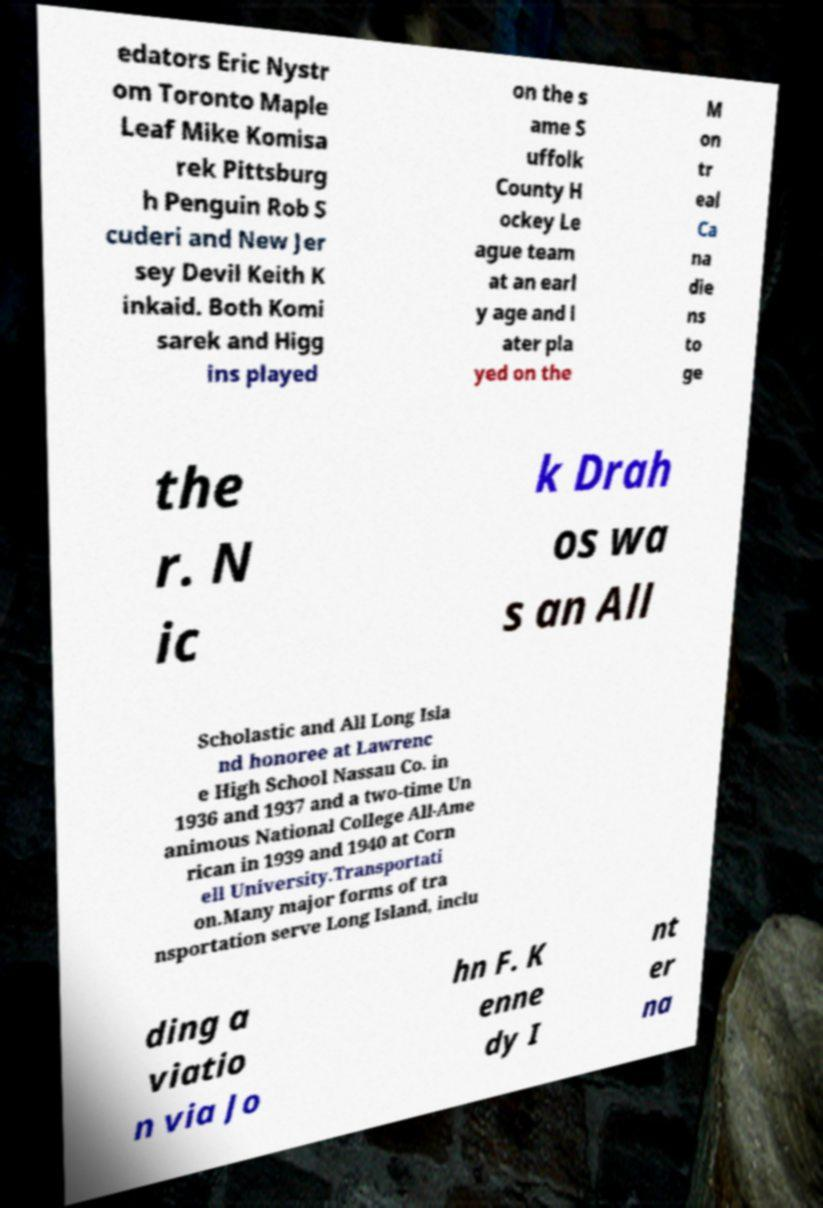I need the written content from this picture converted into text. Can you do that? edators Eric Nystr om Toronto Maple Leaf Mike Komisa rek Pittsburg h Penguin Rob S cuderi and New Jer sey Devil Keith K inkaid. Both Komi sarek and Higg ins played on the s ame S uffolk County H ockey Le ague team at an earl y age and l ater pla yed on the M on tr eal Ca na die ns to ge the r. N ic k Drah os wa s an All Scholastic and All Long Isla nd honoree at Lawrenc e High School Nassau Co. in 1936 and 1937 and a two-time Un animous National College All-Ame rican in 1939 and 1940 at Corn ell University.Transportati on.Many major forms of tra nsportation serve Long Island, inclu ding a viatio n via Jo hn F. K enne dy I nt er na 